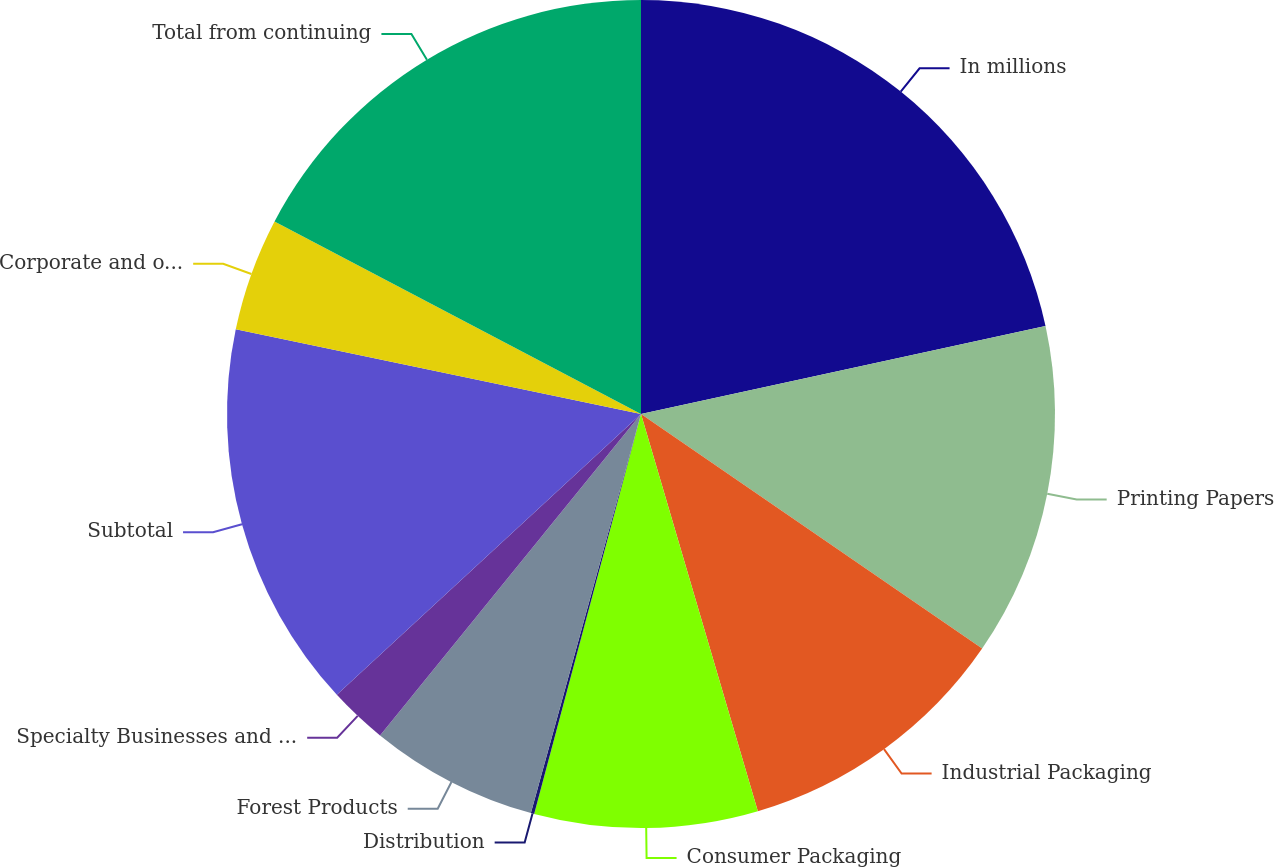Convert chart to OTSL. <chart><loc_0><loc_0><loc_500><loc_500><pie_chart><fcel>In millions<fcel>Printing Papers<fcel>Industrial Packaging<fcel>Consumer Packaging<fcel>Distribution<fcel>Forest Products<fcel>Specialty Businesses and Other<fcel>Subtotal<fcel>Corporate and other<fcel>Total from continuing<nl><fcel>21.59%<fcel>13.0%<fcel>10.86%<fcel>8.71%<fcel>0.13%<fcel>6.57%<fcel>2.28%<fcel>15.15%<fcel>4.42%<fcel>17.3%<nl></chart> 